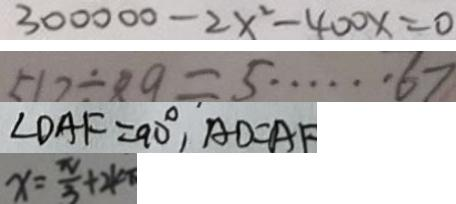<formula> <loc_0><loc_0><loc_500><loc_500>3 0 0 0 0 0 - 2 x ^ { 2 } - 4 0 0 x = 0 
 5 1 2 \div 8 9 = 5 \cdots 6 7 
 \angle D A F = 9 0 ^ { \circ } , A D = A F 
 x = \frac { \pi } { 3 } + 2 k \pi</formula> 